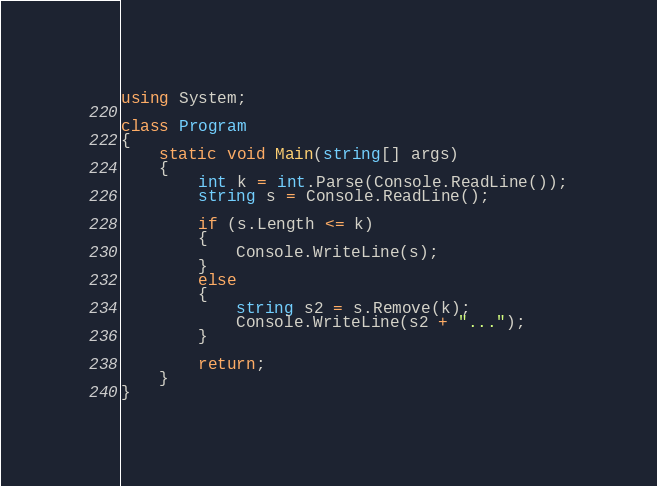<code> <loc_0><loc_0><loc_500><loc_500><_C#_>using System;

class Program
{
	static void Main(string[] args)
	{
		int k = int.Parse(Console.ReadLine());
		string s = Console.ReadLine();

		if (s.Length <= k)
		{
			Console.WriteLine(s);
		}
		else
		{
			string s2 = s.Remove(k);
			Console.WriteLine(s2 + "...");
		}

		return;
	}
}</code> 